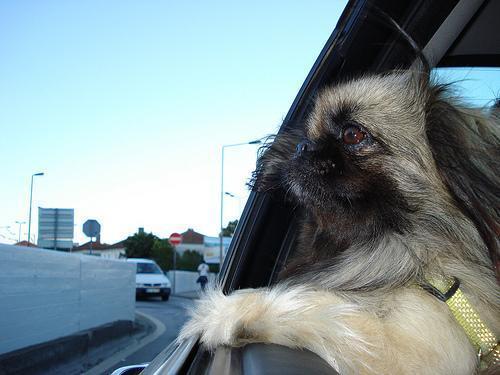How many dogs are there?
Give a very brief answer. 1. 